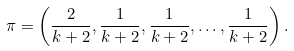Convert formula to latex. <formula><loc_0><loc_0><loc_500><loc_500>\pi = \left ( \frac { 2 } { k + 2 } , \frac { 1 } { k + 2 } , \frac { 1 } { k + 2 } , \dots , \frac { 1 } { k + 2 } \right ) .</formula> 